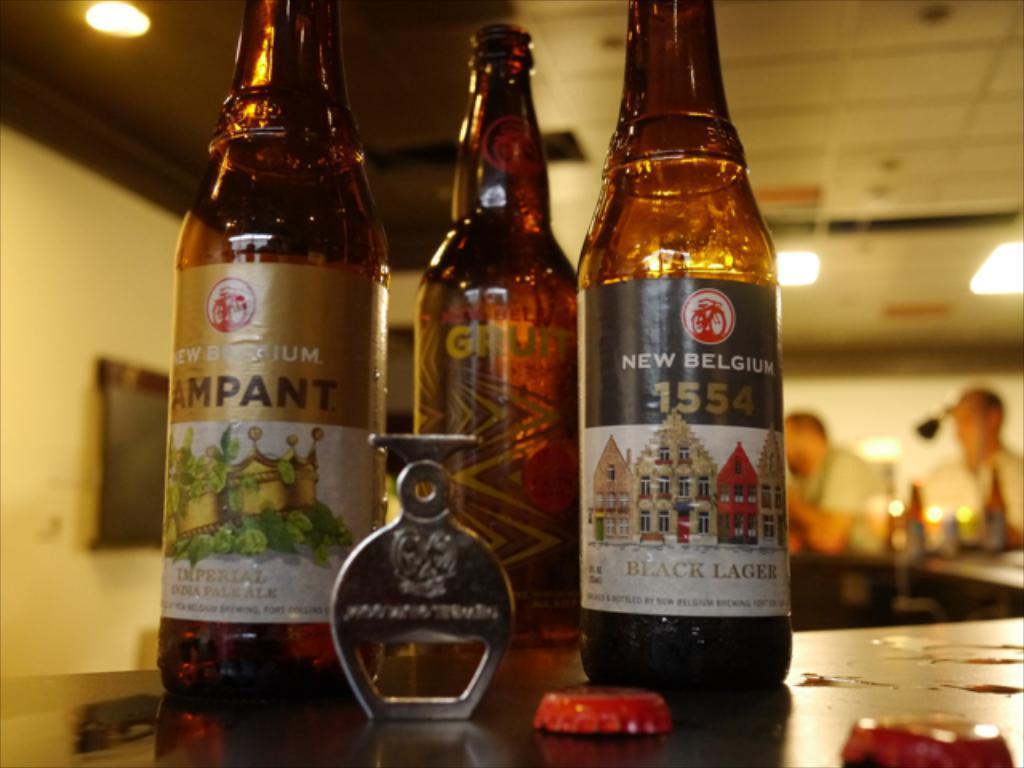How would you summarize this image in a sentence or two? In front of this picture, we see three alcohol bottles which are placed on the table. Beside that on the right corner of the picture, we see two men sitting on the table sitting on chair in front of the table. In the left corner of the picture, we see a black board on a white wall and above the picture, we see the ceiling of that room. 